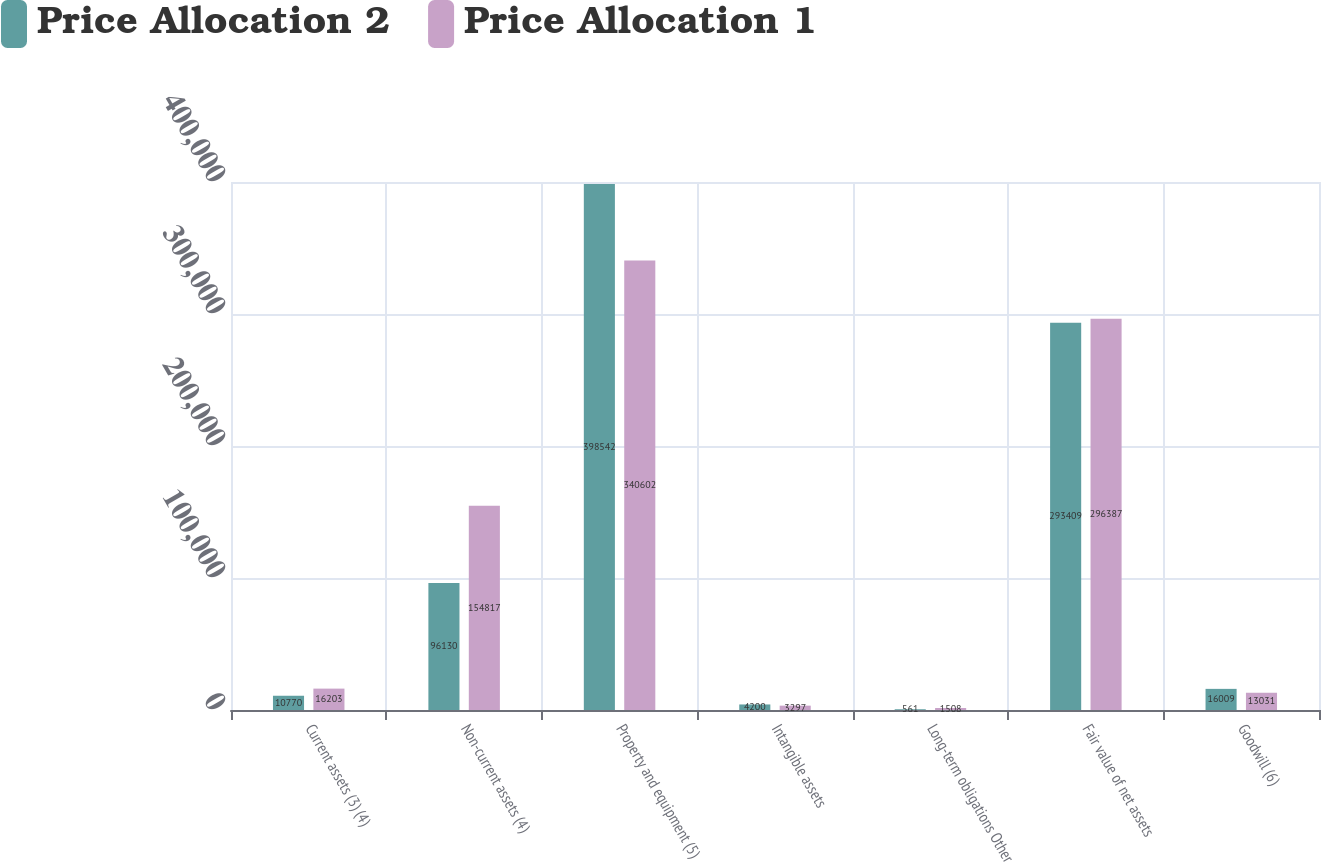<chart> <loc_0><loc_0><loc_500><loc_500><stacked_bar_chart><ecel><fcel>Current assets (3) (4)<fcel>Non-current assets (4)<fcel>Property and equipment (5)<fcel>Intangible assets<fcel>Long-term obligations Other<fcel>Fair value of net assets<fcel>Goodwill (6)<nl><fcel>Price Allocation 2<fcel>10770<fcel>96130<fcel>398542<fcel>4200<fcel>561<fcel>293409<fcel>16009<nl><fcel>Price Allocation 1<fcel>16203<fcel>154817<fcel>340602<fcel>3297<fcel>1508<fcel>296387<fcel>13031<nl></chart> 